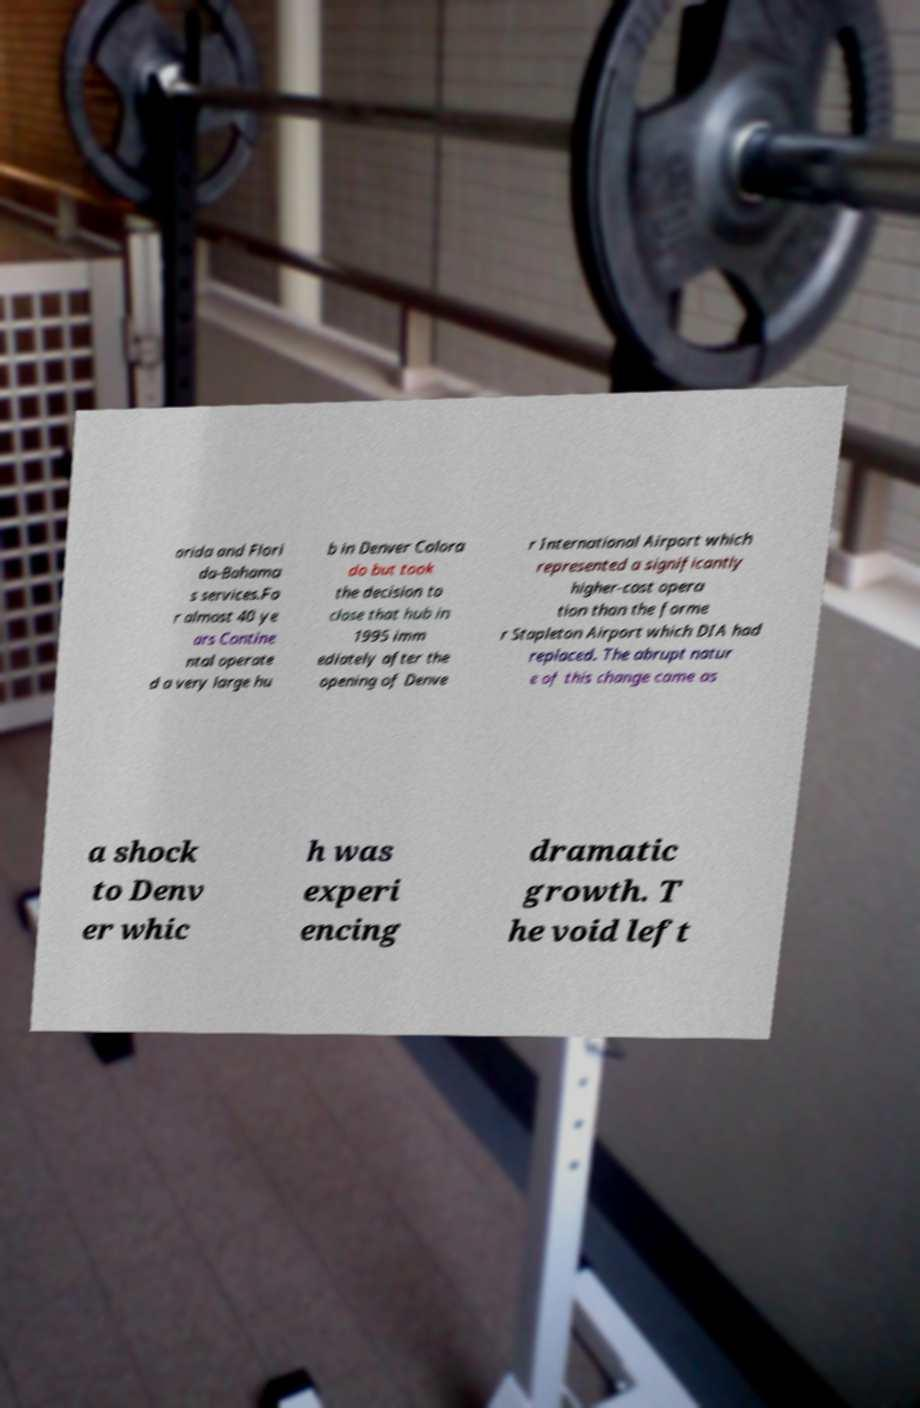Please read and relay the text visible in this image. What does it say? orida and Flori da-Bahama s services.Fo r almost 40 ye ars Contine ntal operate d a very large hu b in Denver Colora do but took the decision to close that hub in 1995 imm ediately after the opening of Denve r International Airport which represented a significantly higher-cost opera tion than the forme r Stapleton Airport which DIA had replaced. The abrupt natur e of this change came as a shock to Denv er whic h was experi encing dramatic growth. T he void left 